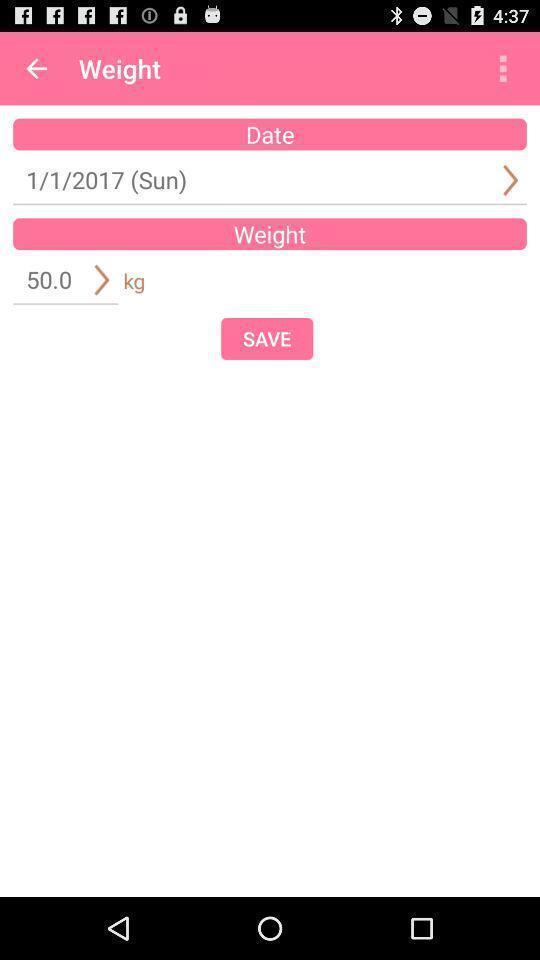Summarize the main components in this picture. Weight information in the mobile application to save. 